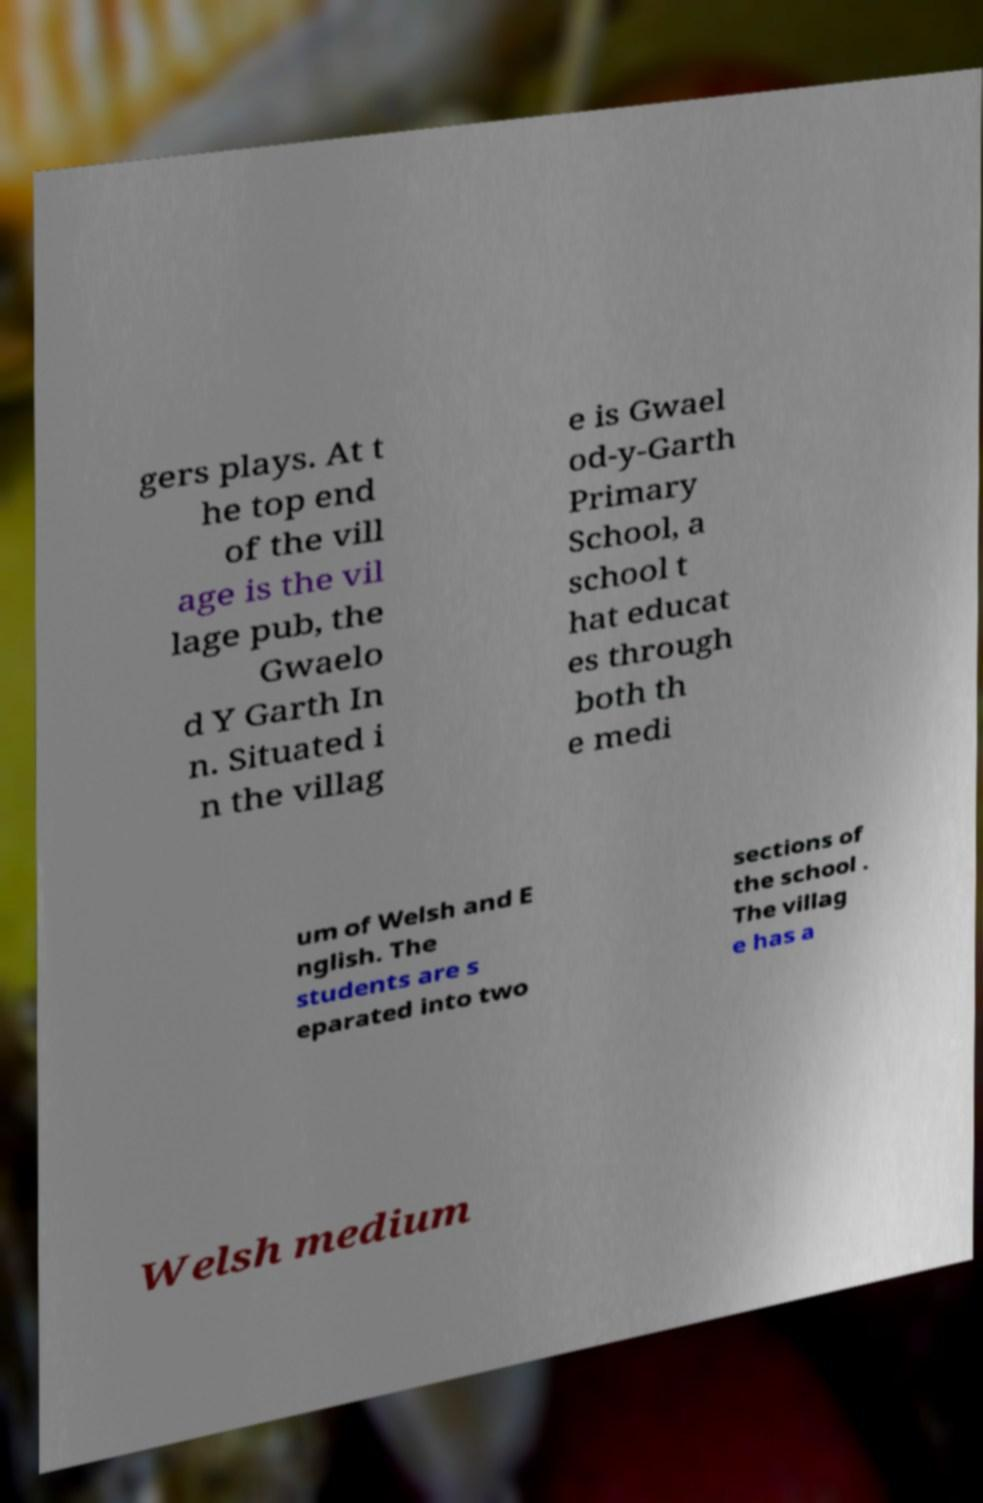Can you accurately transcribe the text from the provided image for me? gers plays. At t he top end of the vill age is the vil lage pub, the Gwaelo d Y Garth In n. Situated i n the villag e is Gwael od-y-Garth Primary School, a school t hat educat es through both th e medi um of Welsh and E nglish. The students are s eparated into two sections of the school . The villag e has a Welsh medium 